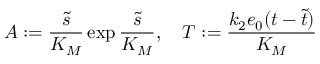Convert formula to latex. <formula><loc_0><loc_0><loc_500><loc_500>A \colon = \frac { \widetilde { s } } { K _ { M } } \exp \frac { \widetilde { s } } { K _ { M } } , \quad T \colon = \frac { k _ { 2 } e _ { 0 } ( t - \widetilde { t } ) } { K _ { M } }</formula> 